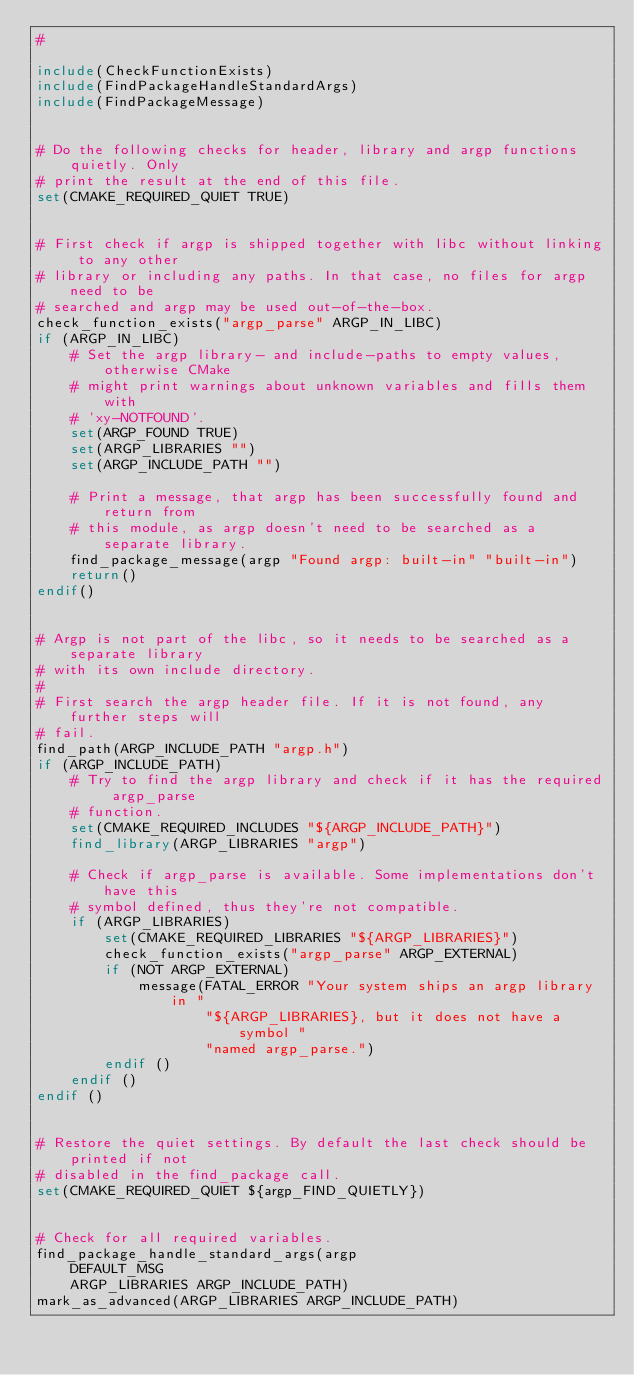<code> <loc_0><loc_0><loc_500><loc_500><_CMake_>#

include(CheckFunctionExists)
include(FindPackageHandleStandardArgs)
include(FindPackageMessage)


# Do the following checks for header, library and argp functions quietly. Only
# print the result at the end of this file.
set(CMAKE_REQUIRED_QUIET TRUE)


# First check if argp is shipped together with libc without linking to any other
# library or including any paths. In that case, no files for argp need to be
# searched and argp may be used out-of-the-box.
check_function_exists("argp_parse" ARGP_IN_LIBC)
if (ARGP_IN_LIBC)
	# Set the argp library- and include-paths to empty values, otherwise CMake
	# might print warnings about unknown variables and fills them with
	# 'xy-NOTFOUND'.
	set(ARGP_FOUND TRUE)
	set(ARGP_LIBRARIES "")
	set(ARGP_INCLUDE_PATH "")

	# Print a message, that argp has been successfully found and return from
	# this module, as argp doesn't need to be searched as a separate library.
	find_package_message(argp "Found argp: built-in" "built-in")
	return()
endif()


# Argp is not part of the libc, so it needs to be searched as a separate library
# with its own include directory.
#
# First search the argp header file. If it is not found, any further steps will
# fail.
find_path(ARGP_INCLUDE_PATH "argp.h")
if (ARGP_INCLUDE_PATH)
    # Try to find the argp library and check if it has the required argp_parse
    # function.
	set(CMAKE_REQUIRED_INCLUDES "${ARGP_INCLUDE_PATH}")
    find_library(ARGP_LIBRARIES "argp")

    # Check if argp_parse is available. Some implementations don't have this
    # symbol defined, thus they're not compatible.
    if (ARGP_LIBRARIES)
        set(CMAKE_REQUIRED_LIBRARIES "${ARGP_LIBRARIES}")
        check_function_exists("argp_parse" ARGP_EXTERNAL)
        if (NOT ARGP_EXTERNAL)
            message(FATAL_ERROR "Your system ships an argp library in "
                    "${ARGP_LIBRARIES}, but it does not have a symbol "
                    "named argp_parse.")
        endif ()
    endif ()
endif ()


# Restore the quiet settings. By default the last check should be printed if not
# disabled in the find_package call.
set(CMAKE_REQUIRED_QUIET ${argp_FIND_QUIETLY})


# Check for all required variables.
find_package_handle_standard_args(argp
	DEFAULT_MSG
	ARGP_LIBRARIES ARGP_INCLUDE_PATH)
mark_as_advanced(ARGP_LIBRARIES ARGP_INCLUDE_PATH)

</code> 